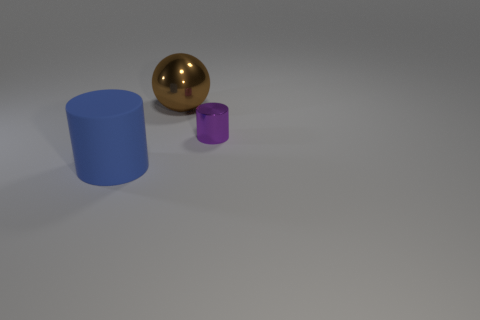How do the shapes of the objects compare? The scene contains three objects of distinct shapes: a sphere, a tall cylinder, and a small, short cylinder. The spherical object is unique as it displays no edges or vertices, while both cylindrical objects have circular bases with one being significantly taller and having a larger diameter than the other. 